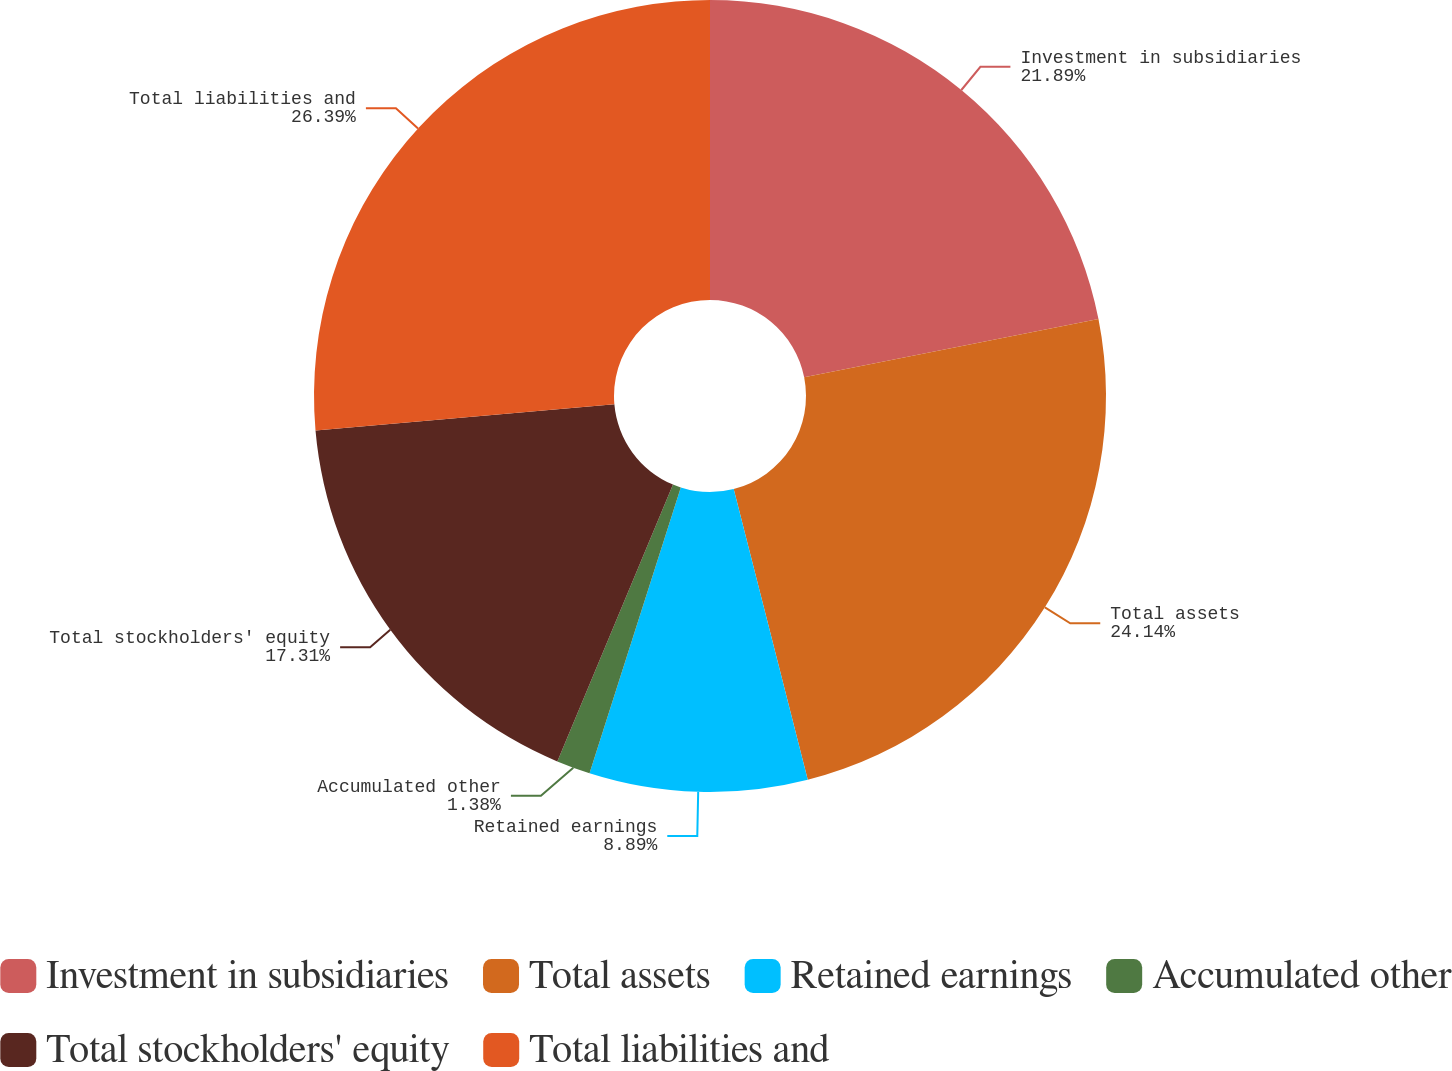<chart> <loc_0><loc_0><loc_500><loc_500><pie_chart><fcel>Investment in subsidiaries<fcel>Total assets<fcel>Retained earnings<fcel>Accumulated other<fcel>Total stockholders' equity<fcel>Total liabilities and<nl><fcel>21.89%<fcel>24.14%<fcel>8.89%<fcel>1.38%<fcel>17.31%<fcel>26.39%<nl></chart> 